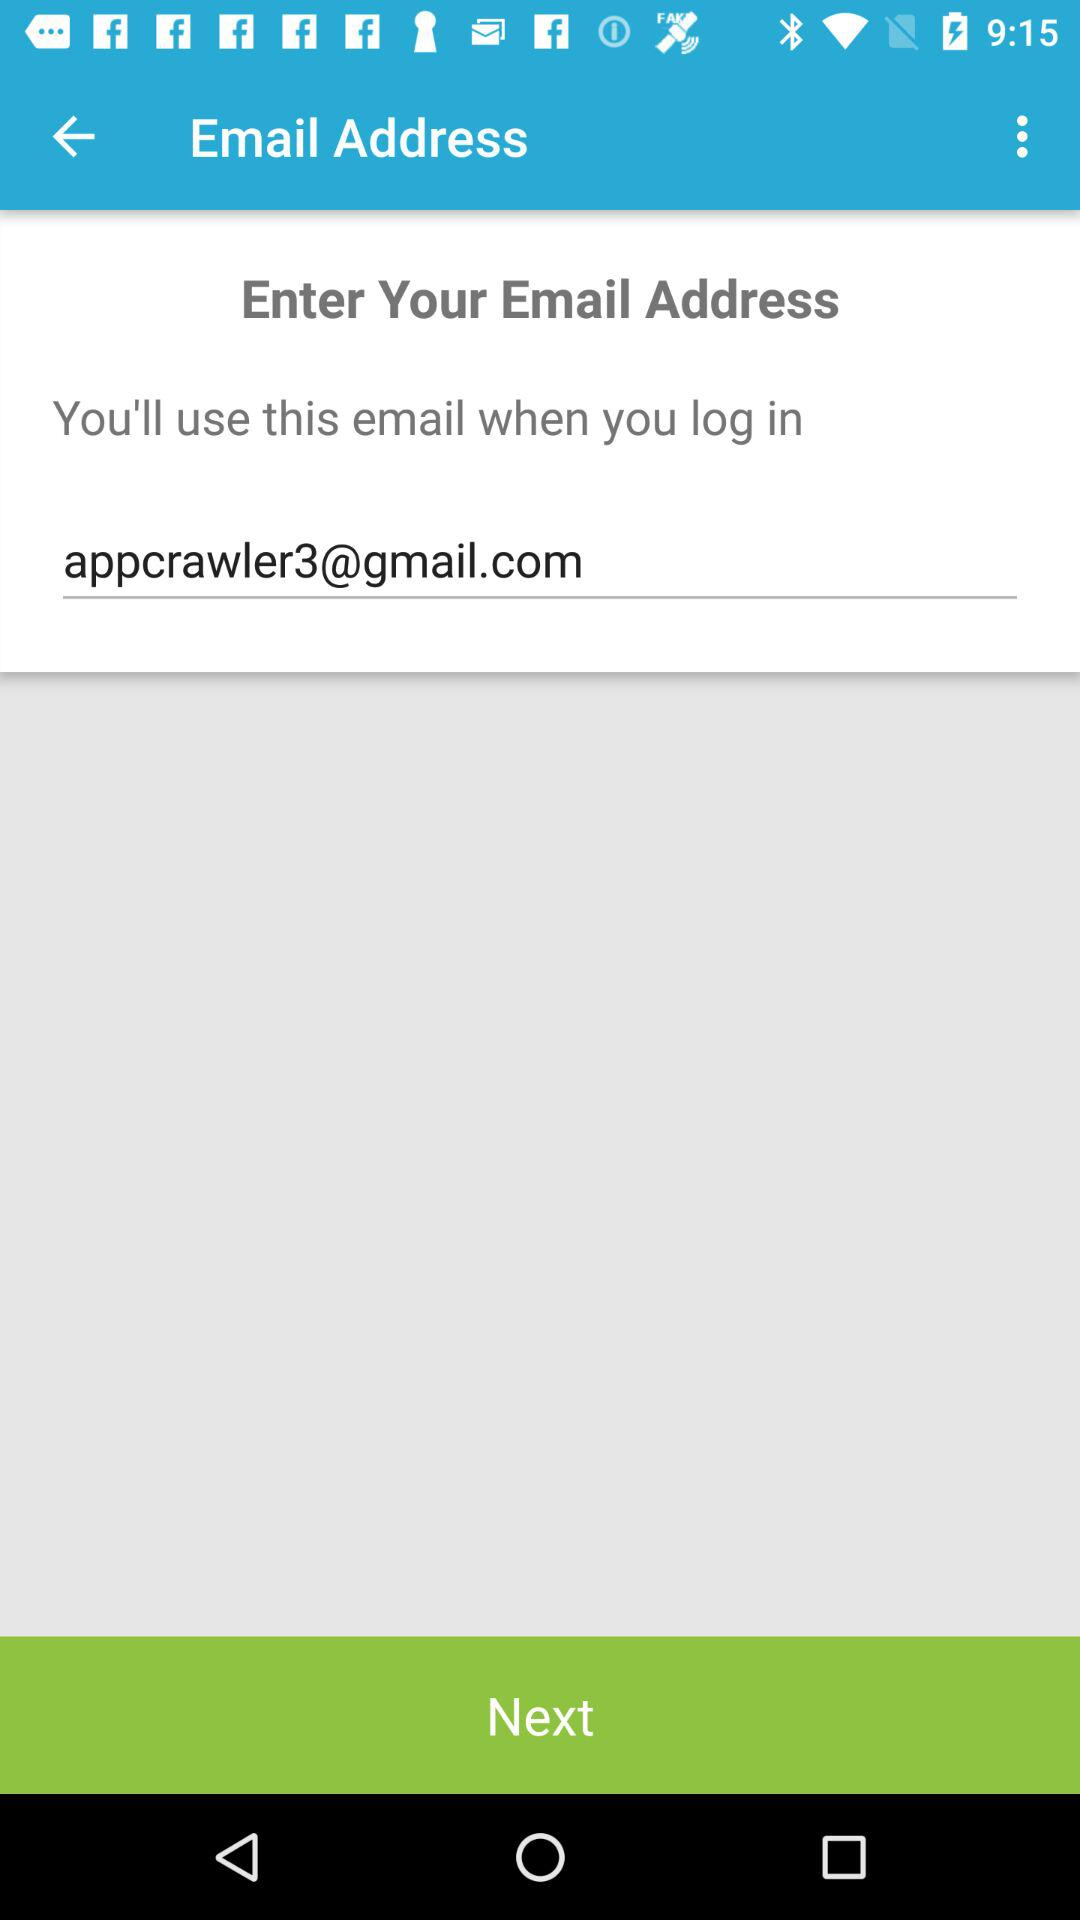What is the email address? The email address is appcrawler3@gmail.com. 